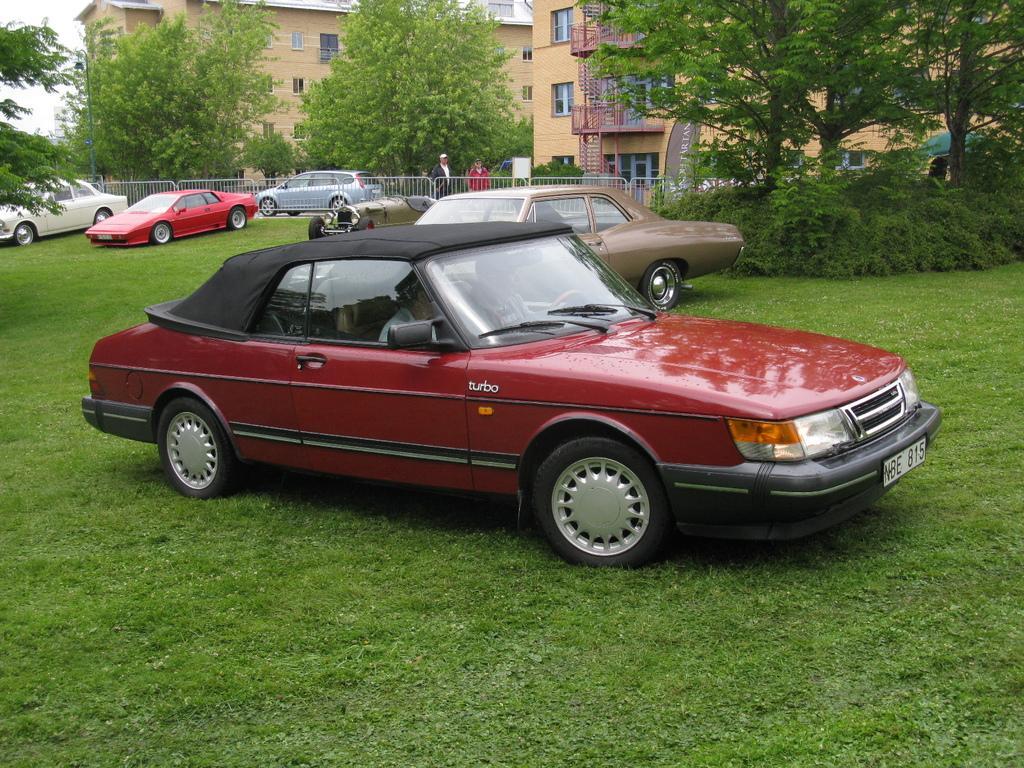How would you summarize this image in a sentence or two? This image is taken outdoors. At the bottom of the image there is a ground with grass on it. In the background there are a few buildings. There are a few trees and plants with leaves, stems and branches. There is a board with a text on it. There is a fence. A few cars are parked on the ground. Two persons are standing on the ground. In the middle of the image a few cars are parked on the ground. 